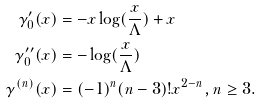<formula> <loc_0><loc_0><loc_500><loc_500>\gamma _ { 0 } ^ { \prime } ( x ) & = - x \log ( \frac { x } { \Lambda } ) + x \\ \gamma _ { 0 } ^ { \prime \prime } ( x ) & = - \log ( \frac { x } { \Lambda } ) \\ \gamma ^ { ( n ) } ( x ) & = ( - 1 ) ^ { n } ( n - 3 ) ! x ^ { 2 - n } , n \geq 3 .</formula> 